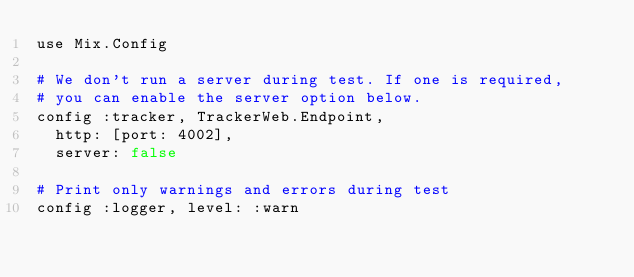Convert code to text. <code><loc_0><loc_0><loc_500><loc_500><_Elixir_>use Mix.Config

# We don't run a server during test. If one is required,
# you can enable the server option below.
config :tracker, TrackerWeb.Endpoint,
  http: [port: 4002],
  server: false

# Print only warnings and errors during test
config :logger, level: :warn
</code> 